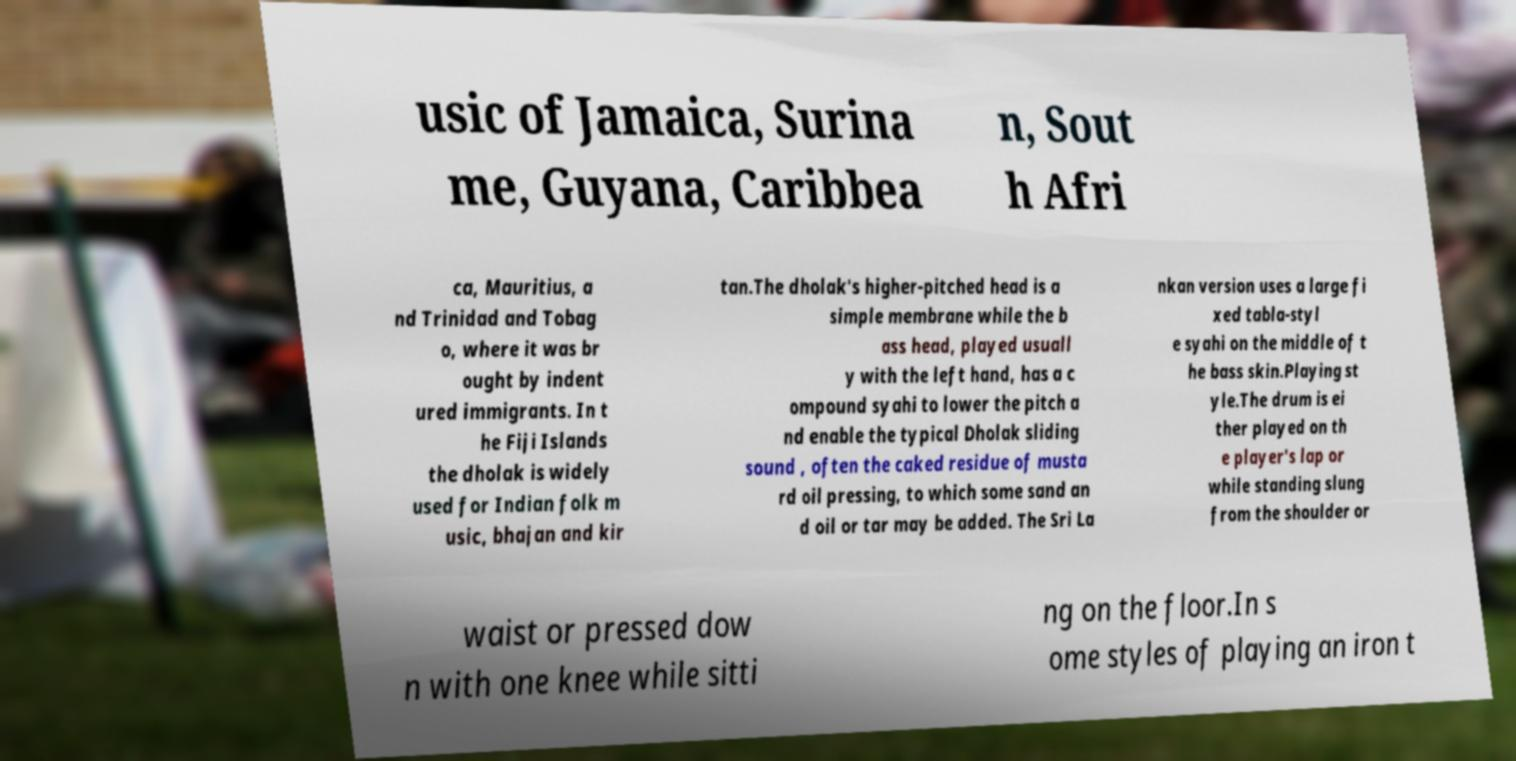What messages or text are displayed in this image? I need them in a readable, typed format. usic of Jamaica, Surina me, Guyana, Caribbea n, Sout h Afri ca, Mauritius, a nd Trinidad and Tobag o, where it was br ought by indent ured immigrants. In t he Fiji Islands the dholak is widely used for Indian folk m usic, bhajan and kir tan.The dholak's higher-pitched head is a simple membrane while the b ass head, played usuall y with the left hand, has a c ompound syahi to lower the pitch a nd enable the typical Dholak sliding sound , often the caked residue of musta rd oil pressing, to which some sand an d oil or tar may be added. The Sri La nkan version uses a large fi xed tabla-styl e syahi on the middle of t he bass skin.Playing st yle.The drum is ei ther played on th e player's lap or while standing slung from the shoulder or waist or pressed dow n with one knee while sitti ng on the floor.In s ome styles of playing an iron t 